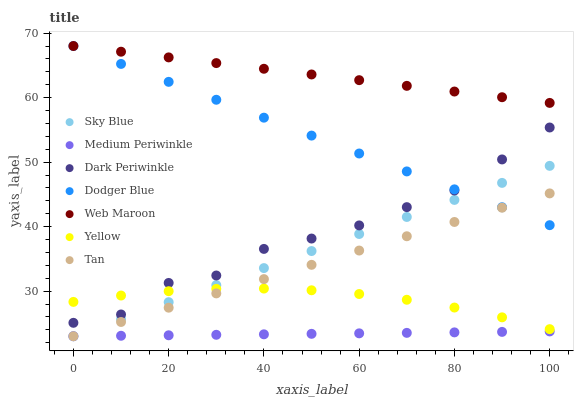Does Medium Periwinkle have the minimum area under the curve?
Answer yes or no. Yes. Does Web Maroon have the maximum area under the curve?
Answer yes or no. Yes. Does Yellow have the minimum area under the curve?
Answer yes or no. No. Does Yellow have the maximum area under the curve?
Answer yes or no. No. Is Dodger Blue the smoothest?
Answer yes or no. Yes. Is Dark Periwinkle the roughest?
Answer yes or no. Yes. Is Web Maroon the smoothest?
Answer yes or no. No. Is Web Maroon the roughest?
Answer yes or no. No. Does Medium Periwinkle have the lowest value?
Answer yes or no. Yes. Does Yellow have the lowest value?
Answer yes or no. No. Does Dodger Blue have the highest value?
Answer yes or no. Yes. Does Yellow have the highest value?
Answer yes or no. No. Is Yellow less than Web Maroon?
Answer yes or no. Yes. Is Dodger Blue greater than Medium Periwinkle?
Answer yes or no. Yes. Does Sky Blue intersect Yellow?
Answer yes or no. Yes. Is Sky Blue less than Yellow?
Answer yes or no. No. Is Sky Blue greater than Yellow?
Answer yes or no. No. Does Yellow intersect Web Maroon?
Answer yes or no. No. 